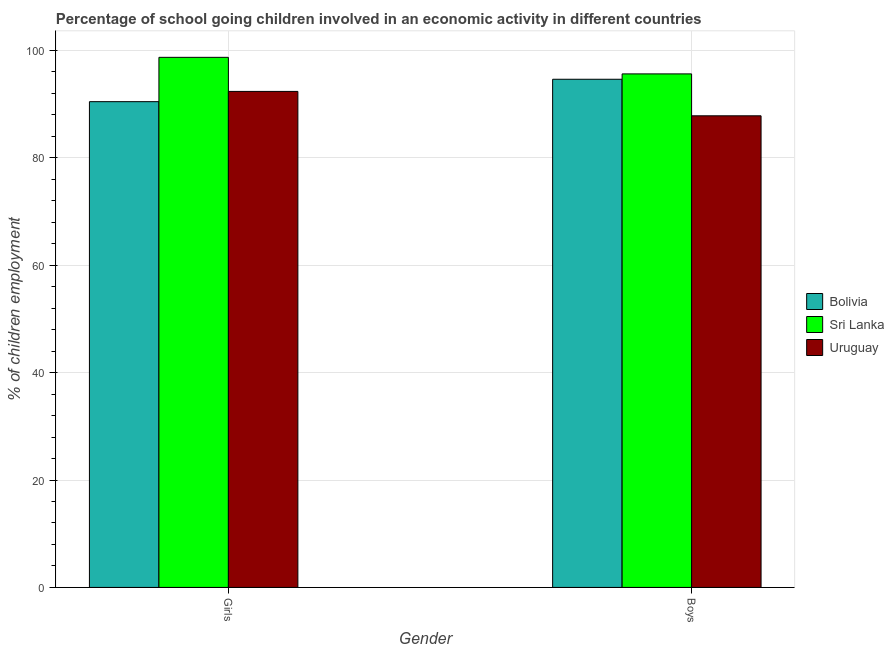How many different coloured bars are there?
Offer a terse response. 3. How many groups of bars are there?
Keep it short and to the point. 2. Are the number of bars per tick equal to the number of legend labels?
Your answer should be very brief. Yes. Are the number of bars on each tick of the X-axis equal?
Give a very brief answer. Yes. How many bars are there on the 1st tick from the left?
Offer a very short reply. 3. What is the label of the 2nd group of bars from the left?
Make the answer very short. Boys. What is the percentage of school going boys in Bolivia?
Offer a very short reply. 94.62. Across all countries, what is the maximum percentage of school going boys?
Provide a short and direct response. 95.62. Across all countries, what is the minimum percentage of school going girls?
Offer a very short reply. 90.45. In which country was the percentage of school going girls maximum?
Make the answer very short. Sri Lanka. In which country was the percentage of school going girls minimum?
Offer a terse response. Bolivia. What is the total percentage of school going boys in the graph?
Your answer should be compact. 278.06. What is the difference between the percentage of school going boys in Sri Lanka and that in Bolivia?
Make the answer very short. 1. What is the difference between the percentage of school going boys in Uruguay and the percentage of school going girls in Sri Lanka?
Make the answer very short. -10.89. What is the average percentage of school going boys per country?
Make the answer very short. 92.69. What is the difference between the percentage of school going boys and percentage of school going girls in Sri Lanka?
Offer a very short reply. -3.08. What is the ratio of the percentage of school going girls in Uruguay to that in Sri Lanka?
Offer a terse response. 0.94. Is the percentage of school going boys in Sri Lanka less than that in Uruguay?
Your answer should be very brief. No. What does the 3rd bar from the left in Girls represents?
Provide a succinct answer. Uruguay. What does the 1st bar from the right in Boys represents?
Give a very brief answer. Uruguay. How many bars are there?
Your response must be concise. 6. Are all the bars in the graph horizontal?
Provide a succinct answer. No. How many countries are there in the graph?
Give a very brief answer. 3. What is the difference between two consecutive major ticks on the Y-axis?
Provide a succinct answer. 20. Does the graph contain grids?
Make the answer very short. Yes. Where does the legend appear in the graph?
Ensure brevity in your answer.  Center right. How many legend labels are there?
Your response must be concise. 3. What is the title of the graph?
Keep it short and to the point. Percentage of school going children involved in an economic activity in different countries. What is the label or title of the X-axis?
Your answer should be compact. Gender. What is the label or title of the Y-axis?
Your answer should be very brief. % of children employment. What is the % of children employment in Bolivia in Girls?
Provide a succinct answer. 90.45. What is the % of children employment in Sri Lanka in Girls?
Provide a short and direct response. 98.71. What is the % of children employment of Uruguay in Girls?
Your answer should be very brief. 92.36. What is the % of children employment in Bolivia in Boys?
Your answer should be very brief. 94.62. What is the % of children employment in Sri Lanka in Boys?
Provide a succinct answer. 95.62. What is the % of children employment in Uruguay in Boys?
Your response must be concise. 87.82. Across all Gender, what is the maximum % of children employment of Bolivia?
Give a very brief answer. 94.62. Across all Gender, what is the maximum % of children employment in Sri Lanka?
Keep it short and to the point. 98.71. Across all Gender, what is the maximum % of children employment of Uruguay?
Your answer should be very brief. 92.36. Across all Gender, what is the minimum % of children employment of Bolivia?
Make the answer very short. 90.45. Across all Gender, what is the minimum % of children employment in Sri Lanka?
Give a very brief answer. 95.62. Across all Gender, what is the minimum % of children employment in Uruguay?
Your answer should be compact. 87.82. What is the total % of children employment in Bolivia in the graph?
Offer a very short reply. 185.07. What is the total % of children employment of Sri Lanka in the graph?
Your response must be concise. 194.33. What is the total % of children employment in Uruguay in the graph?
Make the answer very short. 180.18. What is the difference between the % of children employment of Bolivia in Girls and that in Boys?
Provide a succinct answer. -4.17. What is the difference between the % of children employment in Sri Lanka in Girls and that in Boys?
Make the answer very short. 3.08. What is the difference between the % of children employment of Uruguay in Girls and that in Boys?
Offer a terse response. 4.54. What is the difference between the % of children employment in Bolivia in Girls and the % of children employment in Sri Lanka in Boys?
Give a very brief answer. -5.17. What is the difference between the % of children employment of Bolivia in Girls and the % of children employment of Uruguay in Boys?
Your response must be concise. 2.63. What is the difference between the % of children employment in Sri Lanka in Girls and the % of children employment in Uruguay in Boys?
Provide a short and direct response. 10.89. What is the average % of children employment in Bolivia per Gender?
Your answer should be compact. 92.54. What is the average % of children employment of Sri Lanka per Gender?
Your answer should be very brief. 97.16. What is the average % of children employment in Uruguay per Gender?
Offer a very short reply. 90.09. What is the difference between the % of children employment in Bolivia and % of children employment in Sri Lanka in Girls?
Your answer should be compact. -8.25. What is the difference between the % of children employment in Bolivia and % of children employment in Uruguay in Girls?
Your response must be concise. -1.91. What is the difference between the % of children employment in Sri Lanka and % of children employment in Uruguay in Girls?
Give a very brief answer. 6.35. What is the difference between the % of children employment in Bolivia and % of children employment in Sri Lanka in Boys?
Offer a very short reply. -1. What is the difference between the % of children employment in Bolivia and % of children employment in Uruguay in Boys?
Offer a very short reply. 6.8. What is the difference between the % of children employment in Sri Lanka and % of children employment in Uruguay in Boys?
Provide a short and direct response. 7.8. What is the ratio of the % of children employment of Bolivia in Girls to that in Boys?
Your response must be concise. 0.96. What is the ratio of the % of children employment of Sri Lanka in Girls to that in Boys?
Your answer should be very brief. 1.03. What is the ratio of the % of children employment in Uruguay in Girls to that in Boys?
Make the answer very short. 1.05. What is the difference between the highest and the second highest % of children employment of Bolivia?
Make the answer very short. 4.17. What is the difference between the highest and the second highest % of children employment of Sri Lanka?
Offer a very short reply. 3.08. What is the difference between the highest and the second highest % of children employment in Uruguay?
Your answer should be compact. 4.54. What is the difference between the highest and the lowest % of children employment in Bolivia?
Offer a very short reply. 4.17. What is the difference between the highest and the lowest % of children employment in Sri Lanka?
Your answer should be compact. 3.08. What is the difference between the highest and the lowest % of children employment in Uruguay?
Your response must be concise. 4.54. 